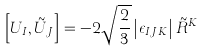<formula> <loc_0><loc_0><loc_500><loc_500>\left [ U _ { I } , \tilde { U } _ { J } \right ] = - 2 \sqrt { \frac { 2 } { 3 } } \left | \epsilon _ { I J K } \right | \tilde { R } ^ { K }</formula> 